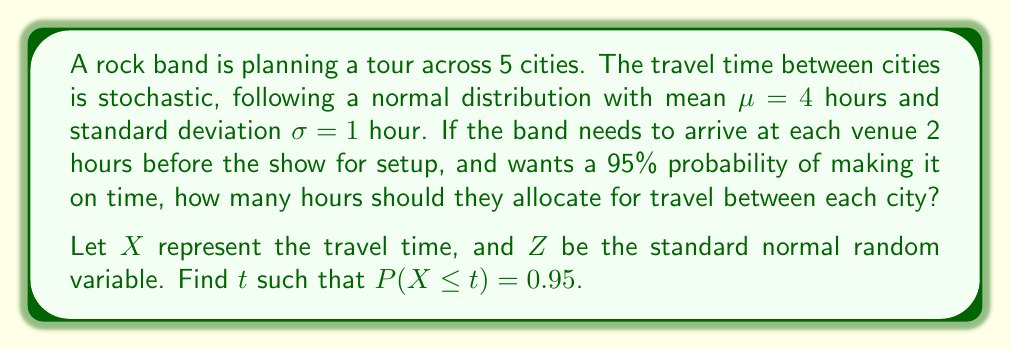Could you help me with this problem? To solve this problem, we'll use the properties of the normal distribution and the concept of z-scores.

Step 1: Identify the given information
- Travel time follows a normal distribution: $X \sim N(\mu, \sigma^2)$
- $\mu = 4$ hours
- $\sigma = 1$ hour
- We need to find $t$ such that $P(X \leq t) = 0.95$

Step 2: Standardize the random variable
We can convert $X$ to a standard normal random variable $Z$ using the formula:
$Z = \frac{X - \mu}{\sigma}$

Step 3: Rewrite the probability in terms of Z
$P(X \leq t) = P(\frac{X - \mu}{\sigma} \leq \frac{t - \mu}{\sigma}) = P(Z \leq \frac{t - 4}{1}) = 0.95$

Step 4: Find the z-score for 95th percentile
From the standard normal table, we know that the z-score for the 95th percentile is approximately 1.645.

Step 5: Solve for t
$\frac{t - 4}{1} = 1.645$
$t - 4 = 1.645$
$t = 5.645$ hours

Step 6: Round up to the nearest quarter hour for practicality
$t \approx 5.75$ hours

Therefore, the band should allocate 5.75 hours for travel between each city to have a 95% probability of arriving on time, considering the 2-hour setup time.
Answer: 5.75 hours 